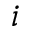Convert formula to latex. <formula><loc_0><loc_0><loc_500><loc_500>i</formula> 